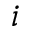Convert formula to latex. <formula><loc_0><loc_0><loc_500><loc_500>i</formula> 